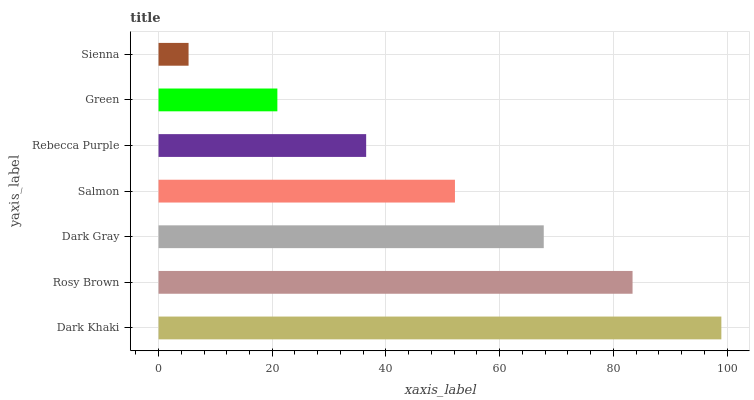Is Sienna the minimum?
Answer yes or no. Yes. Is Dark Khaki the maximum?
Answer yes or no. Yes. Is Rosy Brown the minimum?
Answer yes or no. No. Is Rosy Brown the maximum?
Answer yes or no. No. Is Dark Khaki greater than Rosy Brown?
Answer yes or no. Yes. Is Rosy Brown less than Dark Khaki?
Answer yes or no. Yes. Is Rosy Brown greater than Dark Khaki?
Answer yes or no. No. Is Dark Khaki less than Rosy Brown?
Answer yes or no. No. Is Salmon the high median?
Answer yes or no. Yes. Is Salmon the low median?
Answer yes or no. Yes. Is Dark Gray the high median?
Answer yes or no. No. Is Dark Gray the low median?
Answer yes or no. No. 